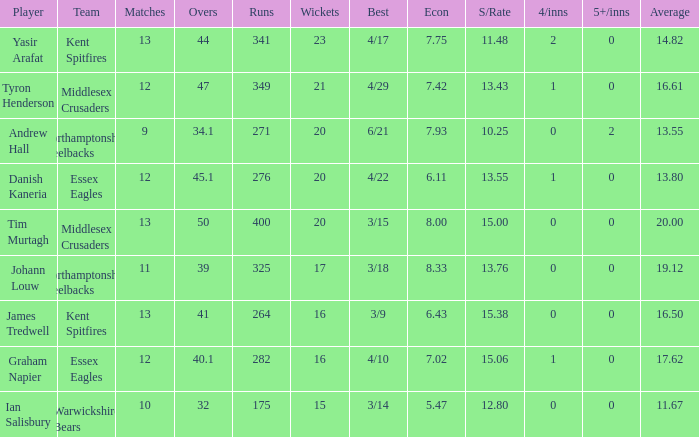List the events involving the 17th wickets. 11.0. 